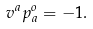Convert formula to latex. <formula><loc_0><loc_0><loc_500><loc_500>v ^ { a } p _ { a } ^ { o } = - 1 .</formula> 